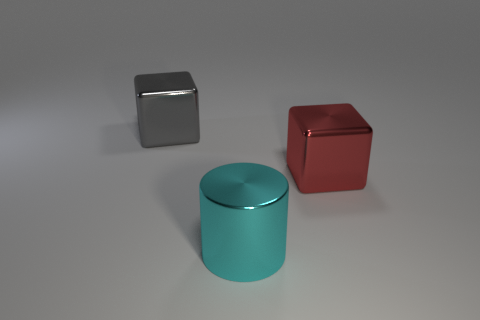How many big red metal blocks are there?
Your response must be concise. 1. Are there an equal number of big gray shiny cubes that are behind the big gray metallic thing and red objects behind the red object?
Ensure brevity in your answer.  Yes. There is a big cyan cylinder; are there any large cyan objects in front of it?
Give a very brief answer. No. What is the color of the large cube that is right of the cyan object?
Provide a succinct answer. Red. What material is the cylinder on the left side of the large cube in front of the gray cube?
Your answer should be very brief. Metal. Are there fewer metallic objects that are to the right of the gray cube than metallic objects on the left side of the red block?
Your answer should be very brief. No. What number of brown things are either shiny things or big rubber cubes?
Offer a very short reply. 0. Are there an equal number of large metallic blocks that are in front of the large cyan metallic cylinder and big blocks?
Make the answer very short. No. What number of objects are either large cyan things or red objects that are on the right side of the large metallic cylinder?
Your answer should be compact. 2. Is there a green sphere that has the same material as the large red block?
Provide a short and direct response. No. 